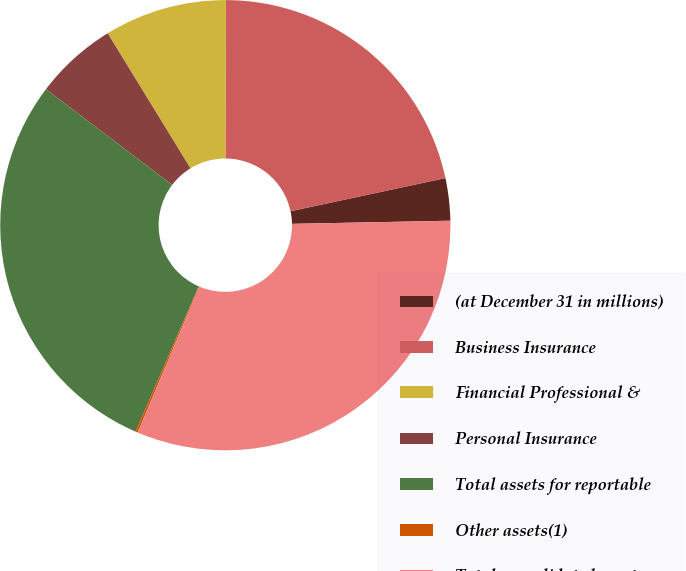Convert chart. <chart><loc_0><loc_0><loc_500><loc_500><pie_chart><fcel>(at December 31 in millions)<fcel>Business Insurance<fcel>Financial Professional &<fcel>Personal Insurance<fcel>Total assets for reportable<fcel>Other assets(1)<fcel>Total consolidated assets<nl><fcel>3.04%<fcel>21.6%<fcel>8.8%<fcel>5.92%<fcel>28.8%<fcel>0.16%<fcel>31.68%<nl></chart> 